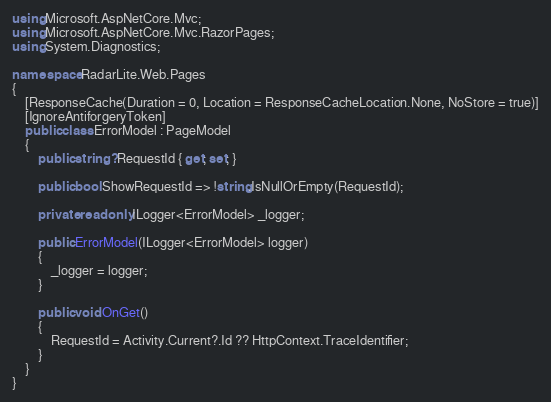Convert code to text. <code><loc_0><loc_0><loc_500><loc_500><_C#_>using Microsoft.AspNetCore.Mvc;
using Microsoft.AspNetCore.Mvc.RazorPages;
using System.Diagnostics;

namespace RadarLite.Web.Pages
{
    [ResponseCache(Duration = 0, Location = ResponseCacheLocation.None, NoStore = true)]
    [IgnoreAntiforgeryToken]
    public class ErrorModel : PageModel
    {
        public string? RequestId { get; set; }

        public bool ShowRequestId => !string.IsNullOrEmpty(RequestId);

        private readonly ILogger<ErrorModel> _logger;

        public ErrorModel(ILogger<ErrorModel> logger)
        {
            _logger = logger;
        }

        public void OnGet()
        {
            RequestId = Activity.Current?.Id ?? HttpContext.TraceIdentifier;
        }
    }
}</code> 